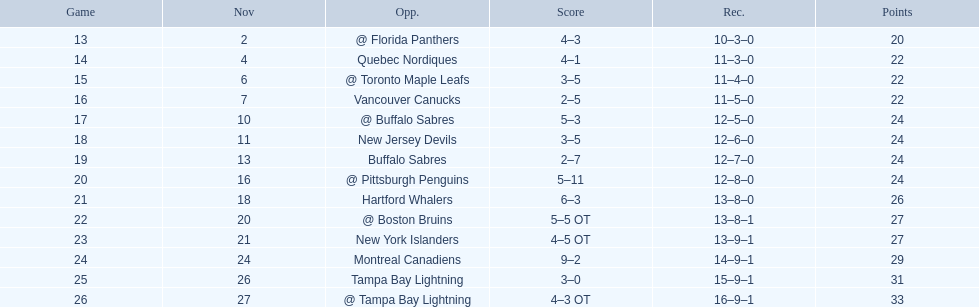Who are all of the teams? @ Florida Panthers, Quebec Nordiques, @ Toronto Maple Leafs, Vancouver Canucks, @ Buffalo Sabres, New Jersey Devils, Buffalo Sabres, @ Pittsburgh Penguins, Hartford Whalers, @ Boston Bruins, New York Islanders, Montreal Canadiens, Tampa Bay Lightning. What games finished in overtime? 22, 23, 26. In game number 23, who did they face? New York Islanders. 